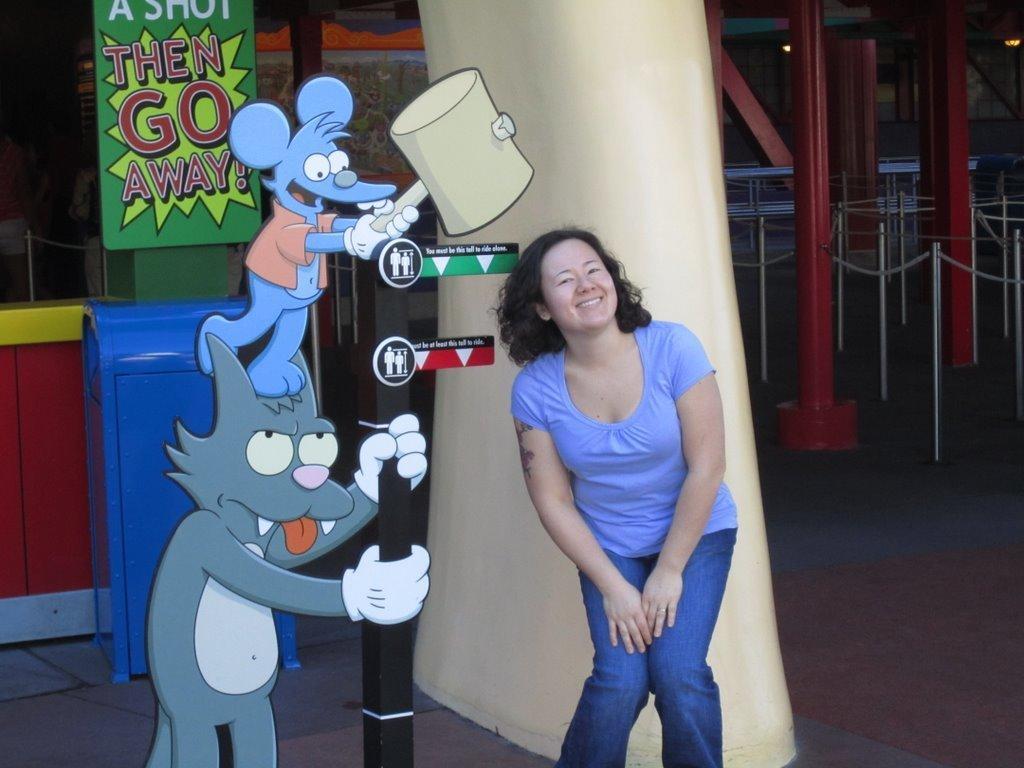Could you give a brief overview of what you see in this image? In this image I can see the person and the person is wearing blue color dress and I can also see few cartoon pictures. In the background I can see few poles, banners, glass wall and few lights. 